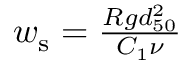<formula> <loc_0><loc_0><loc_500><loc_500>\begin{array} { r } { w _ { s } = \frac { R g d _ { 5 0 } ^ { 2 } } { C _ { 1 } \nu } } \end{array}</formula> 